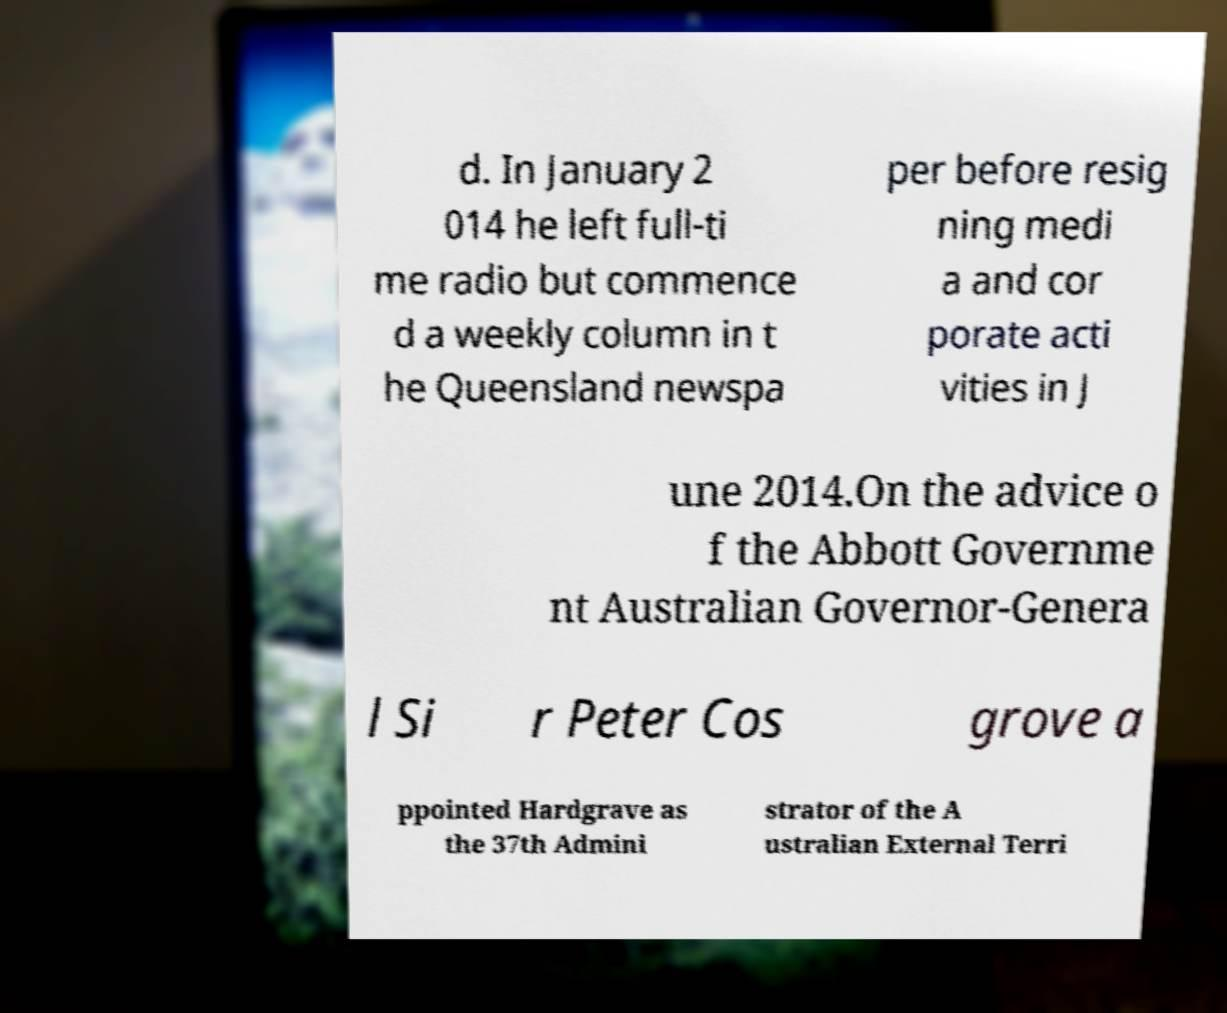There's text embedded in this image that I need extracted. Can you transcribe it verbatim? d. In January 2 014 he left full-ti me radio but commence d a weekly column in t he Queensland newspa per before resig ning medi a and cor porate acti vities in J une 2014.On the advice o f the Abbott Governme nt Australian Governor-Genera l Si r Peter Cos grove a ppointed Hardgrave as the 37th Admini strator of the A ustralian External Terri 